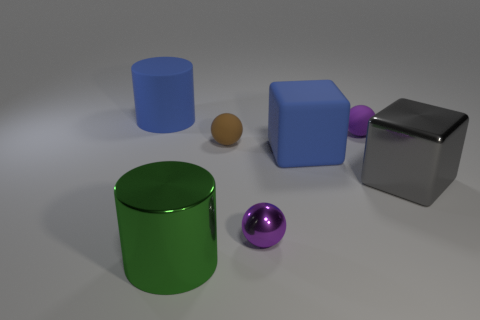Are there any yellow spheres that have the same material as the blue cylinder?
Your response must be concise. No. There is a brown thing that is the same size as the purple matte ball; what is its material?
Offer a terse response. Rubber. Is the number of tiny rubber spheres to the left of the big metal cylinder less than the number of big gray metallic things that are right of the gray object?
Make the answer very short. No. What is the shape of the object that is both in front of the small brown sphere and left of the brown sphere?
Make the answer very short. Cylinder. How many gray metal objects have the same shape as the small brown rubber object?
Ensure brevity in your answer.  0. What is the size of the purple object that is made of the same material as the large green cylinder?
Offer a terse response. Small. Are there more tiny rubber objects than gray shiny cubes?
Offer a terse response. Yes. There is a sphere to the right of the tiny metal object; what is its color?
Provide a short and direct response. Purple. What is the size of the matte thing that is behind the tiny brown object and to the right of the green metal thing?
Provide a short and direct response. Small. How many metal cylinders have the same size as the gray metallic cube?
Ensure brevity in your answer.  1. 